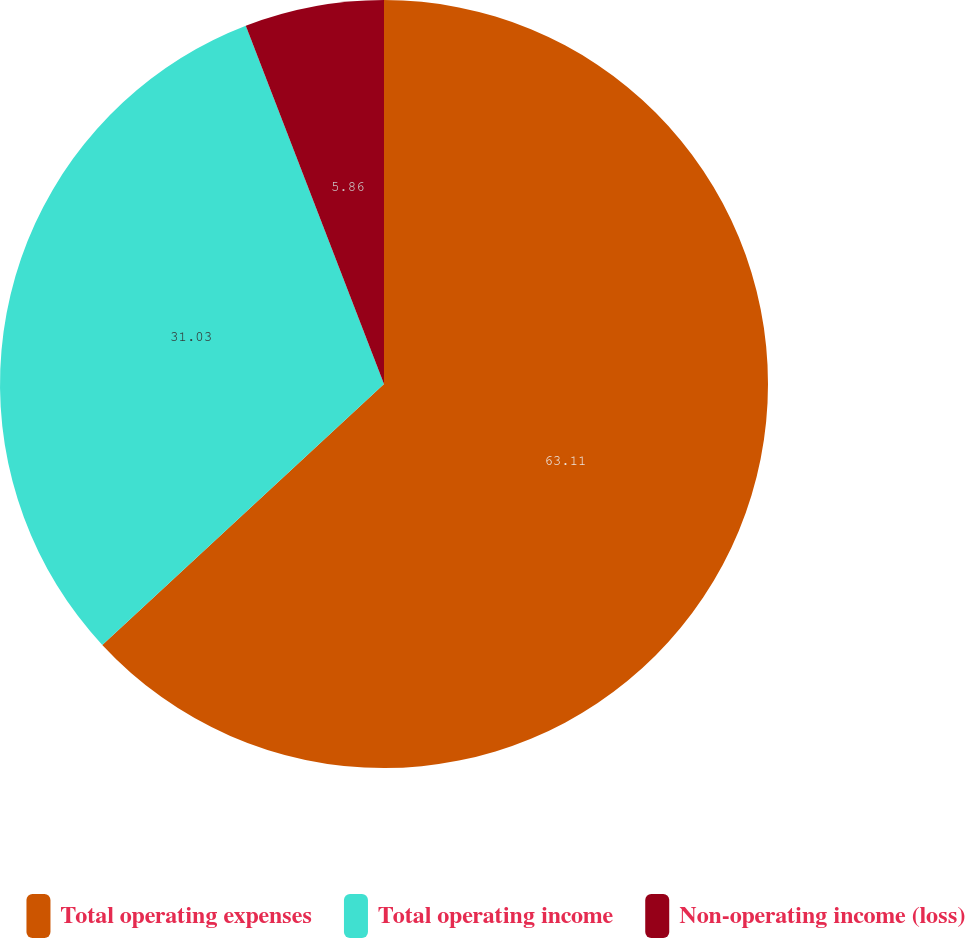Convert chart. <chart><loc_0><loc_0><loc_500><loc_500><pie_chart><fcel>Total operating expenses<fcel>Total operating income<fcel>Non-operating income (loss)<nl><fcel>63.11%<fcel>31.03%<fcel>5.86%<nl></chart> 